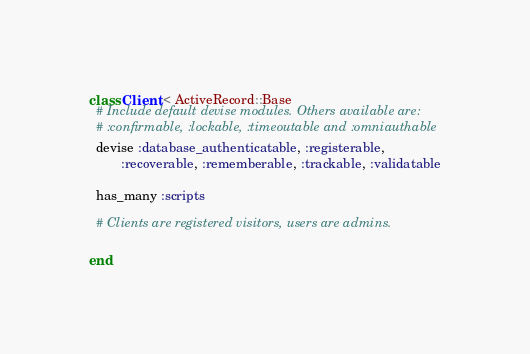<code> <loc_0><loc_0><loc_500><loc_500><_Ruby_>class Client < ActiveRecord::Base
  # Include default devise modules. Others available are:
  # :confirmable, :lockable, :timeoutable and :omniauthable
  devise :database_authenticatable, :registerable,
         :recoverable, :rememberable, :trackable, :validatable
         
  has_many :scripts
  
  # Clients are registered visitors, users are admins.
  
end
</code> 